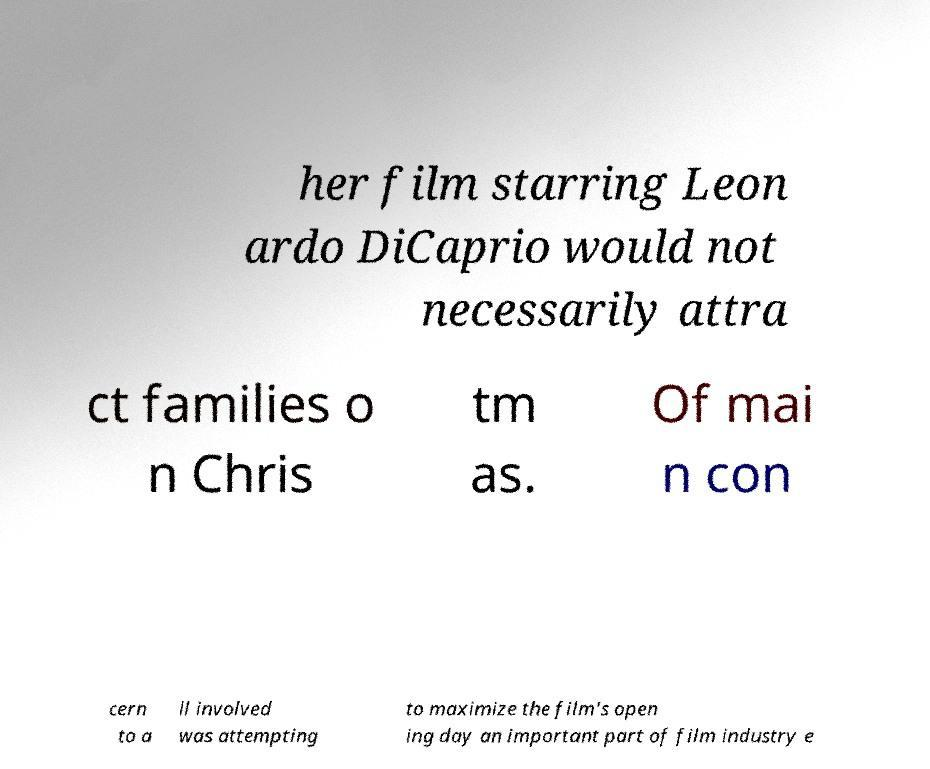Please identify and transcribe the text found in this image. her film starring Leon ardo DiCaprio would not necessarily attra ct families o n Chris tm as. Of mai n con cern to a ll involved was attempting to maximize the film's open ing day an important part of film industry e 